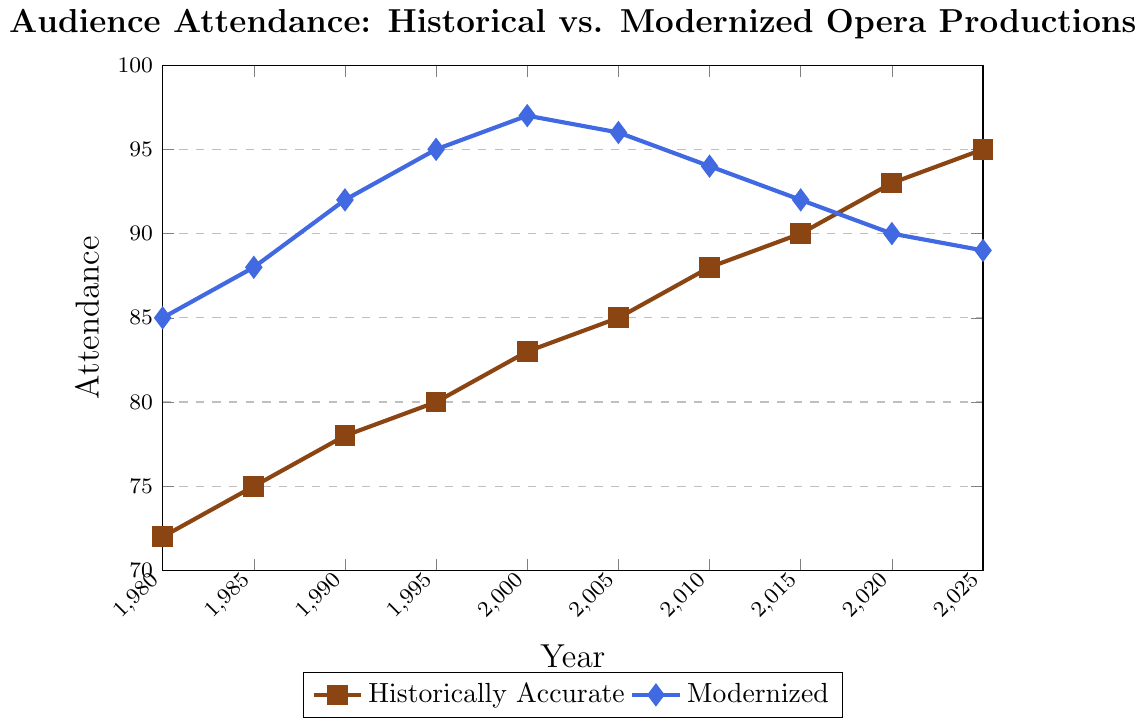What is the trend in audience attendance for historically accurate productions from 1980 to 2025? The trend for historically accurate productions shows a steady increase from 72 in 1980 to 95 in 2025. This indicates a growing interest in historically accurate productions over the years.
Answer: Steady increase Which year had the highest audience attendance for modernized productions? Modernized productions had the highest attendance of 97 in the year 2000. This can be identified by observing the peak point on the blue line.
Answer: 2000 How does the attendance for historically accurate productions in 2025 compare to modernized productions in the same year? In 2025, the attendance for historically accurate productions is 95, whereas for modernized productions it is 89. Therefore, historically accurate productions have a higher attendance by 6.
Answer: Historically accurate is higher by 6 In which year did both historically accurate and modernized productions have exactly the same audience attendance growth compared to their previous values? Comparing year-to-year growth, in 2005 historically accurate productions grew from 83 to 85 (an increase of 2) and modernized productions decreased from 97 to 96 (a decrease of 1). Hence, there is no year with exactly the same audience growth for both.
Answer: No such year What is the average attendance for historically accurate productions over the entire period? To find the average, sum all the attendance values for historically accurate productions and divide by the number of years: (72 + 75 + 78 + 80 + 83 + 85 + 88 + 90 + 93 + 95)/10 = 829/10 = 82.9.
Answer: 82.9 By how much did audience attendance for modernized productions change from 2000 to 2025? Audience attendance for modernized productions decreased from 97 in 2000 to 89 in 2025. The change can be calculated as 97 - 89 = 8.
Answer: Decreased by 8 Which type of production had more consistently increasing audience attendance from 1980 to 2025? Historically accurate productions show a consistently increasing trend, whereas modernized productions have fluctuations, such as decreases after the peak in 2000.
Answer: Historically accurate In which five-year period did historically accurate productions see the smallest growth in audience attendance? From 1980 to 1985, audience attendance for historically accurate productions grew from 72 to 75, a growth of 3, which is the smallest increase compared to other five-year periods.
Answer: 1980 to 1985 Compare the audience attendance trends for both production types from 2010 to 2025. From 2010 to 2025, historically accurate productions continue to increase from 88 to 95, while modernized productions decrease from 94 to 89. The trend shows an increase for historically accurate and a decrease for modernized productions.
Answer: Historically accurate increased, modernized decreased 